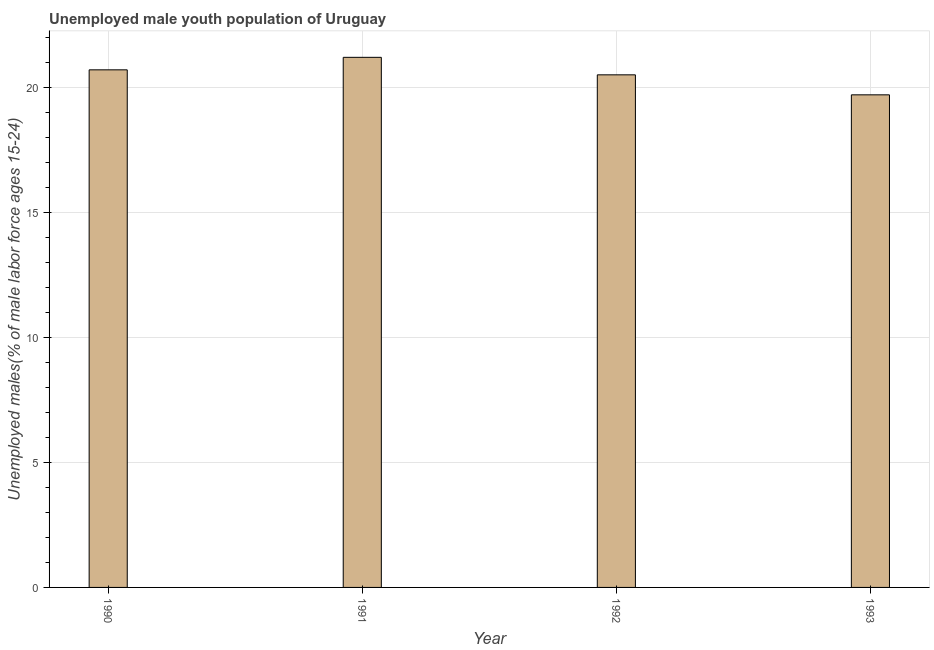What is the title of the graph?
Offer a terse response. Unemployed male youth population of Uruguay. What is the label or title of the X-axis?
Give a very brief answer. Year. What is the label or title of the Y-axis?
Make the answer very short. Unemployed males(% of male labor force ages 15-24). Across all years, what is the maximum unemployed male youth?
Provide a succinct answer. 21.2. Across all years, what is the minimum unemployed male youth?
Make the answer very short. 19.7. In which year was the unemployed male youth maximum?
Offer a very short reply. 1991. What is the sum of the unemployed male youth?
Offer a terse response. 82.1. What is the difference between the unemployed male youth in 1990 and 1992?
Give a very brief answer. 0.2. What is the average unemployed male youth per year?
Provide a succinct answer. 20.52. What is the median unemployed male youth?
Make the answer very short. 20.6. In how many years, is the unemployed male youth greater than 9 %?
Provide a succinct answer. 4. Do a majority of the years between 1990 and 1992 (inclusive) have unemployed male youth greater than 16 %?
Your answer should be very brief. Yes. What is the ratio of the unemployed male youth in 1991 to that in 1993?
Provide a short and direct response. 1.08. Is the difference between the unemployed male youth in 1990 and 1993 greater than the difference between any two years?
Keep it short and to the point. No. In how many years, is the unemployed male youth greater than the average unemployed male youth taken over all years?
Offer a terse response. 2. What is the difference between two consecutive major ticks on the Y-axis?
Offer a terse response. 5. What is the Unemployed males(% of male labor force ages 15-24) in 1990?
Your answer should be very brief. 20.7. What is the Unemployed males(% of male labor force ages 15-24) of 1991?
Give a very brief answer. 21.2. What is the Unemployed males(% of male labor force ages 15-24) of 1992?
Offer a terse response. 20.5. What is the Unemployed males(% of male labor force ages 15-24) of 1993?
Provide a succinct answer. 19.7. What is the difference between the Unemployed males(% of male labor force ages 15-24) in 1990 and 1992?
Provide a succinct answer. 0.2. What is the difference between the Unemployed males(% of male labor force ages 15-24) in 1991 and 1992?
Give a very brief answer. 0.7. What is the difference between the Unemployed males(% of male labor force ages 15-24) in 1991 and 1993?
Your answer should be very brief. 1.5. What is the difference between the Unemployed males(% of male labor force ages 15-24) in 1992 and 1993?
Your answer should be compact. 0.8. What is the ratio of the Unemployed males(% of male labor force ages 15-24) in 1990 to that in 1991?
Keep it short and to the point. 0.98. What is the ratio of the Unemployed males(% of male labor force ages 15-24) in 1990 to that in 1992?
Your response must be concise. 1.01. What is the ratio of the Unemployed males(% of male labor force ages 15-24) in 1990 to that in 1993?
Your answer should be compact. 1.05. What is the ratio of the Unemployed males(% of male labor force ages 15-24) in 1991 to that in 1992?
Offer a very short reply. 1.03. What is the ratio of the Unemployed males(% of male labor force ages 15-24) in 1991 to that in 1993?
Your answer should be compact. 1.08. What is the ratio of the Unemployed males(% of male labor force ages 15-24) in 1992 to that in 1993?
Your answer should be very brief. 1.04. 